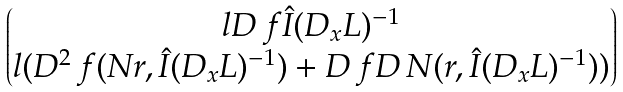<formula> <loc_0><loc_0><loc_500><loc_500>\begin{pmatrix} l D \, f \hat { I } ( D _ { x } L ) ^ { - 1 } \\ l ( D ^ { 2 } \, f ( N r , \hat { I } ( D _ { x } L ) ^ { - 1 } ) + D \, f D \, N ( r , \hat { I } ( D _ { x } L ) ^ { - 1 } ) ) \end{pmatrix}</formula> 